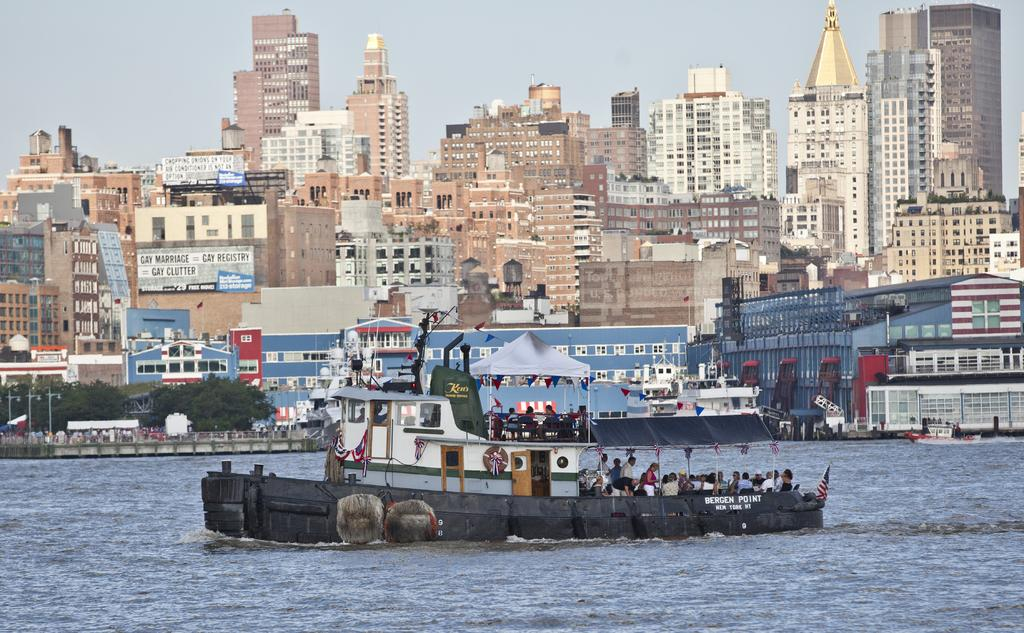What is the main subject of the image? The main subject of the image is a boat. Where is the boat located? The boat is on the water. Are there any people in the boat? Yes, there are people in the boat. What can be seen in the background of the image? There are buildings and trees in the background of the image. What type of hair can be seen on the giraffe in the image? There is no giraffe present in the image, and therefore no hair can be observed. 